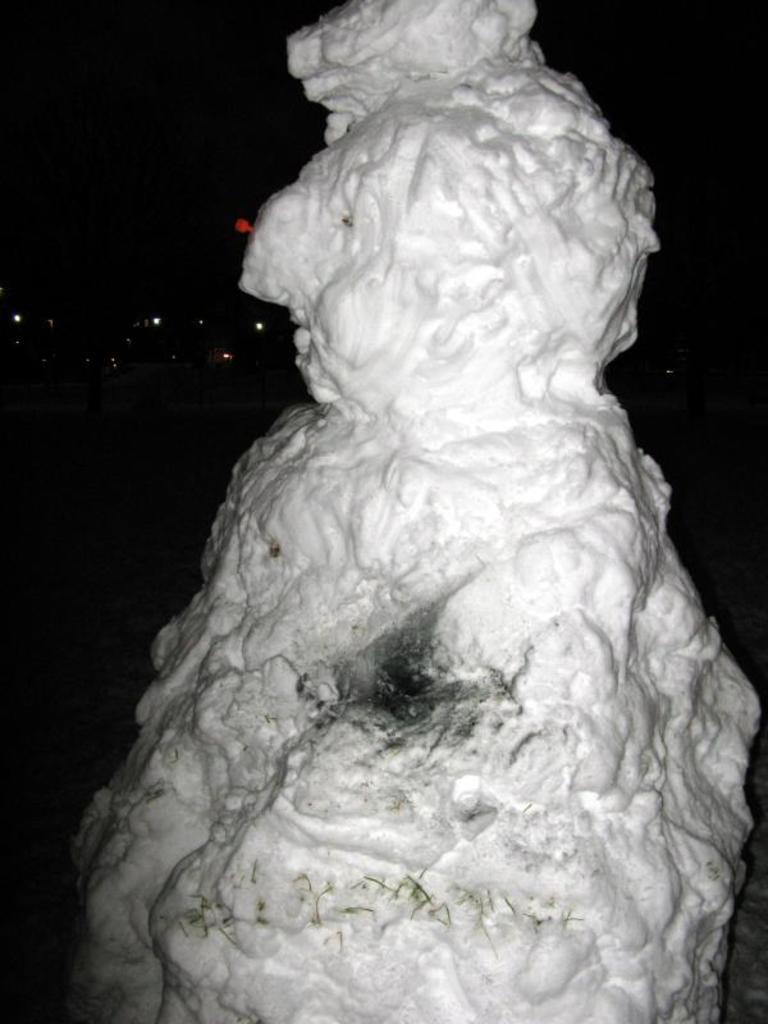How would you summarize this image in a sentence or two? In this image I can see the rock. In the background I can see the lights and there is a black background. 